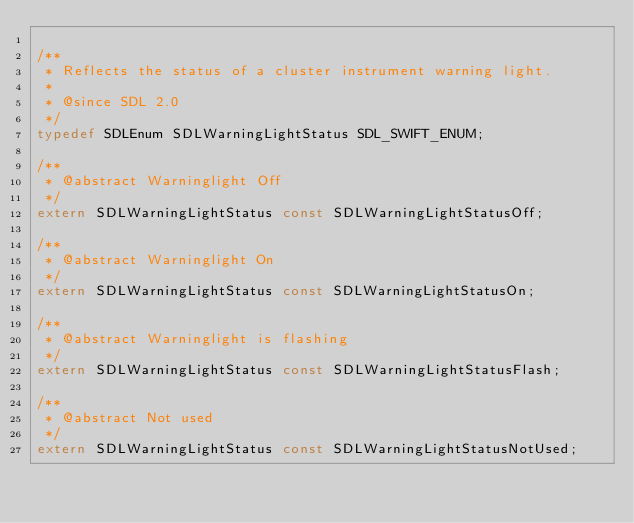Convert code to text. <code><loc_0><loc_0><loc_500><loc_500><_C_>
/**
 * Reflects the status of a cluster instrument warning light.
 *
 * @since SDL 2.0
 */
typedef SDLEnum SDLWarningLightStatus SDL_SWIFT_ENUM;

/**
 * @abstract Warninglight Off
 */
extern SDLWarningLightStatus const SDLWarningLightStatusOff;

/**
 * @abstract Warninglight On
 */
extern SDLWarningLightStatus const SDLWarningLightStatusOn;

/**
 * @abstract Warninglight is flashing
 */
extern SDLWarningLightStatus const SDLWarningLightStatusFlash;

/**
 * @abstract Not used
 */
extern SDLWarningLightStatus const SDLWarningLightStatusNotUsed;
</code> 